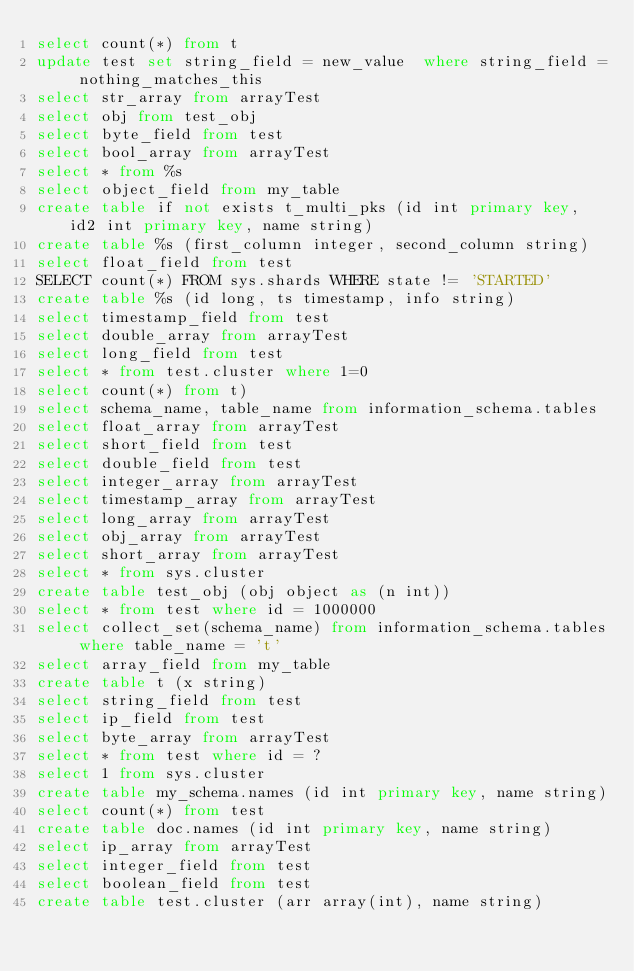Convert code to text. <code><loc_0><loc_0><loc_500><loc_500><_SQL_>select count(*) from t
update test set string_field = new_value  where string_field = nothing_matches_this
select str_array from arrayTest
select obj from test_obj
select byte_field from test
select bool_array from arrayTest
select * from %s
select object_field from my_table
create table if not exists t_multi_pks (id int primary key, id2 int primary key, name string)
create table %s (first_column integer, second_column string)
select float_field from test
SELECT count(*) FROM sys.shards WHERE state != 'STARTED'
create table %s (id long, ts timestamp, info string)
select timestamp_field from test
select double_array from arrayTest
select long_field from test
select * from test.cluster where 1=0
select count(*) from t)
select schema_name, table_name from information_schema.tables 
select float_array from arrayTest
select short_field from test
select double_field from test
select integer_array from arrayTest
select timestamp_array from arrayTest
select long_array from arrayTest
select obj_array from arrayTest
select short_array from arrayTest
select * from sys.cluster
create table test_obj (obj object as (n int))
select * from test where id = 1000000
select collect_set(schema_name) from information_schema.tables where table_name = 't'
select array_field from my_table
create table t (x string)
select string_field from test
select ip_field from test
select byte_array from arrayTest
select * from test where id = ?
select 1 from sys.cluster
create table my_schema.names (id int primary key, name string)
select count(*) from test
create table doc.names (id int primary key, name string)
select ip_array from arrayTest
select integer_field from test
select boolean_field from test
create table test.cluster (arr array(int), name string)
</code> 